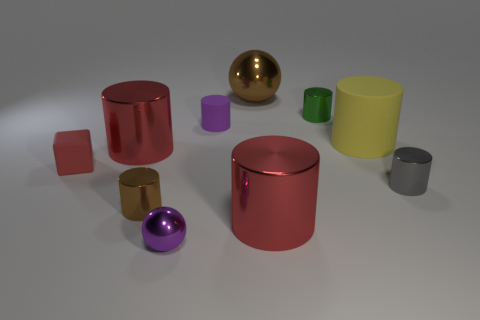Subtract all red cylinders. How many cylinders are left? 5 Subtract 3 cylinders. How many cylinders are left? 4 Subtract all gray shiny cylinders. How many cylinders are left? 6 Subtract all yellow cylinders. Subtract all red balls. How many cylinders are left? 6 Subtract all blocks. How many objects are left? 9 Subtract all tiny spheres. Subtract all red matte blocks. How many objects are left? 8 Add 4 small purple shiny objects. How many small purple shiny objects are left? 5 Add 6 tiny purple metal balls. How many tiny purple metal balls exist? 7 Subtract 1 brown cylinders. How many objects are left? 9 